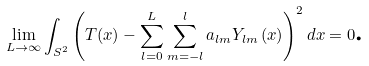<formula> <loc_0><loc_0><loc_500><loc_500>\lim _ { L \rightarrow \infty } \int _ { S ^ { 2 } } \left ( T ( x ) - \sum _ { l = 0 } ^ { L } \sum _ { m = - l } ^ { l } a _ { l m } Y _ { l m } \left ( x \right ) \right ) ^ { 2 } d x = 0 \text {.}</formula> 